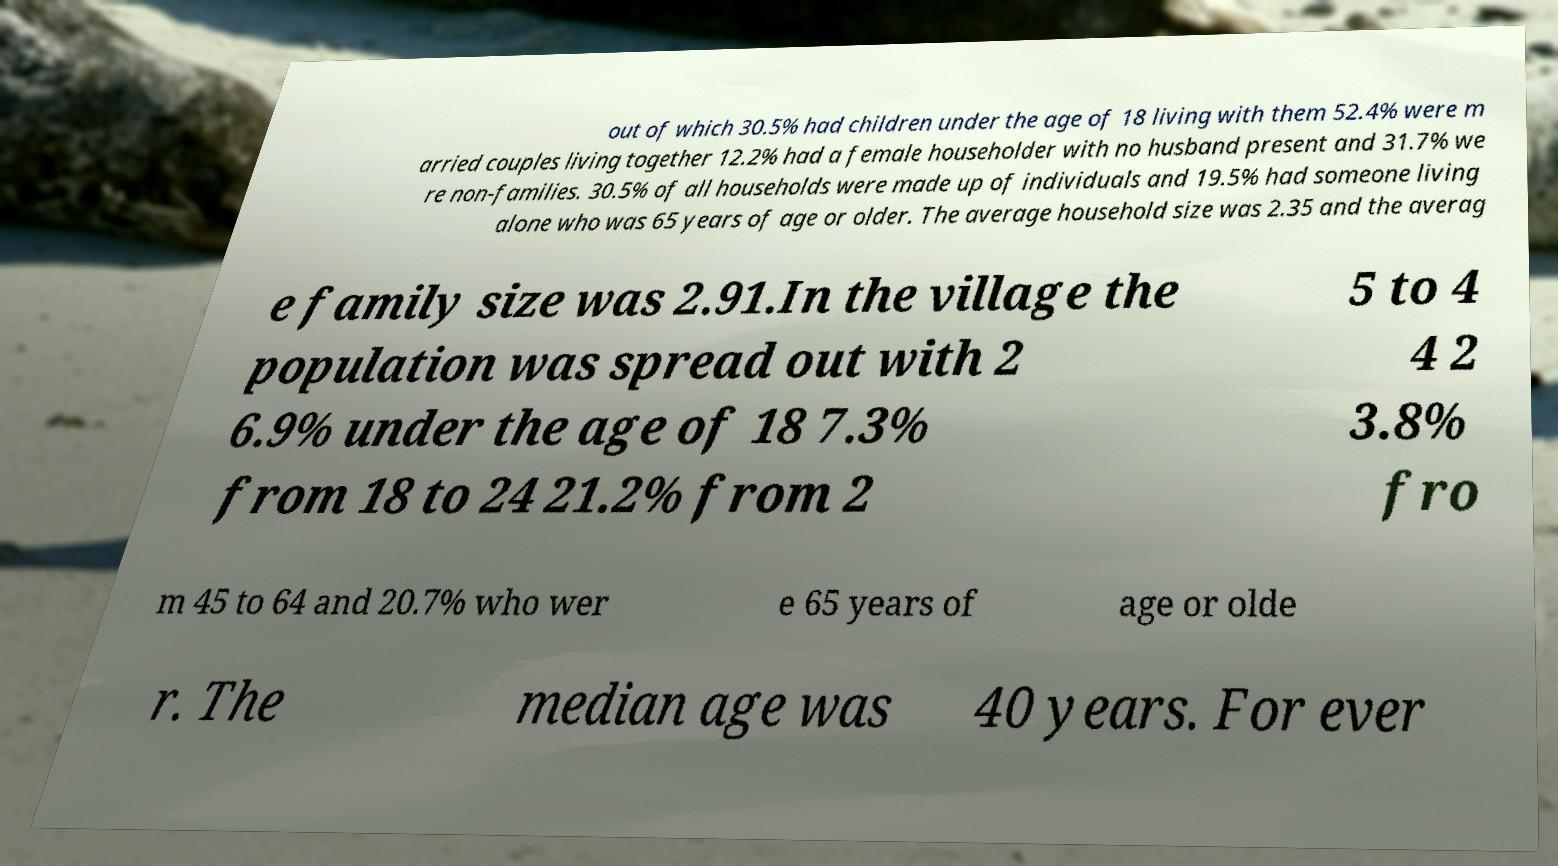I need the written content from this picture converted into text. Can you do that? out of which 30.5% had children under the age of 18 living with them 52.4% were m arried couples living together 12.2% had a female householder with no husband present and 31.7% we re non-families. 30.5% of all households were made up of individuals and 19.5% had someone living alone who was 65 years of age or older. The average household size was 2.35 and the averag e family size was 2.91.In the village the population was spread out with 2 6.9% under the age of 18 7.3% from 18 to 24 21.2% from 2 5 to 4 4 2 3.8% fro m 45 to 64 and 20.7% who wer e 65 years of age or olde r. The median age was 40 years. For ever 